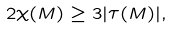<formula> <loc_0><loc_0><loc_500><loc_500>2 \chi ( M ) \geq 3 | \tau ( M ) | ,</formula> 